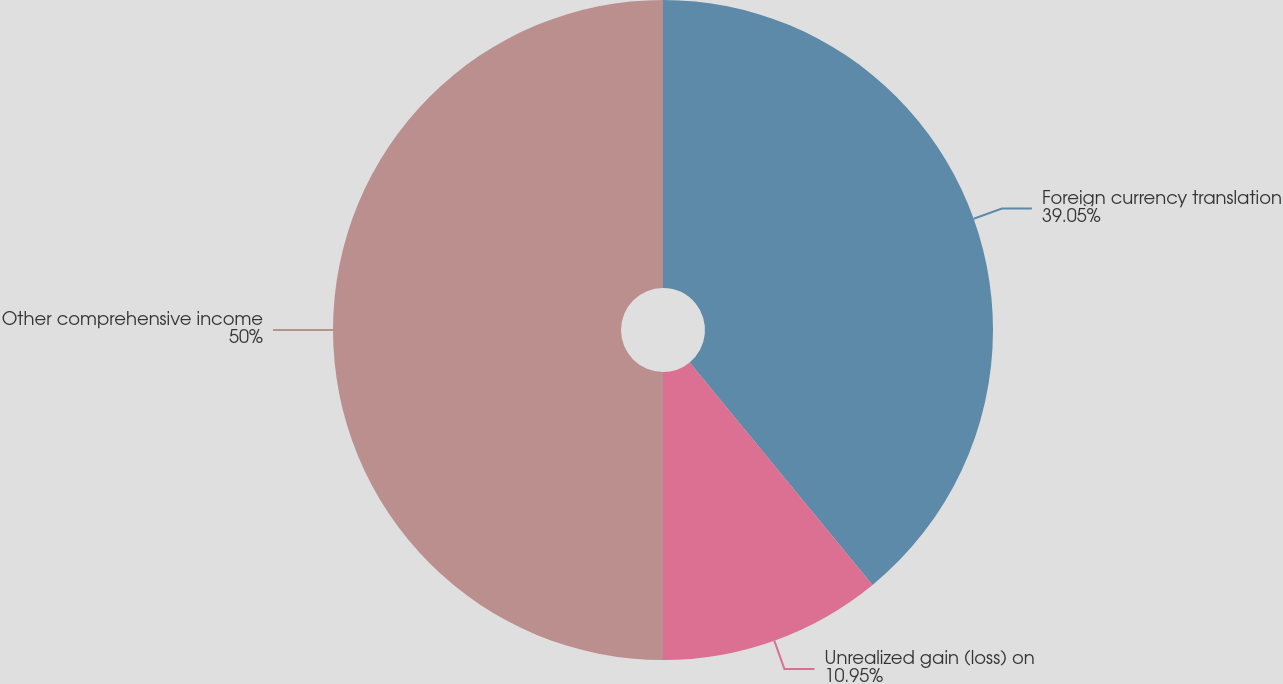<chart> <loc_0><loc_0><loc_500><loc_500><pie_chart><fcel>Foreign currency translation<fcel>Unrealized gain (loss) on<fcel>Other comprehensive income<nl><fcel>39.05%<fcel>10.95%<fcel>50.0%<nl></chart> 